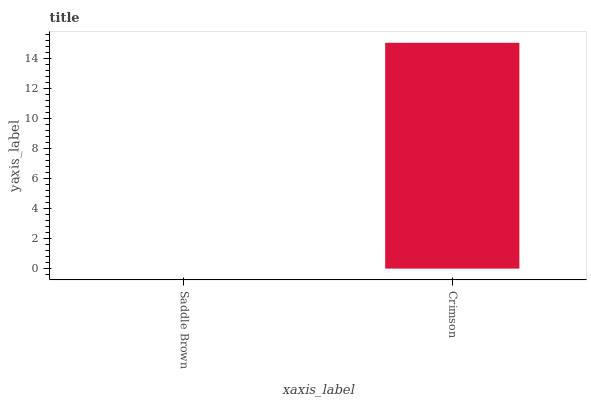Is Saddle Brown the minimum?
Answer yes or no. Yes. Is Crimson the maximum?
Answer yes or no. Yes. Is Crimson the minimum?
Answer yes or no. No. Is Crimson greater than Saddle Brown?
Answer yes or no. Yes. Is Saddle Brown less than Crimson?
Answer yes or no. Yes. Is Saddle Brown greater than Crimson?
Answer yes or no. No. Is Crimson less than Saddle Brown?
Answer yes or no. No. Is Crimson the high median?
Answer yes or no. Yes. Is Saddle Brown the low median?
Answer yes or no. Yes. Is Saddle Brown the high median?
Answer yes or no. No. Is Crimson the low median?
Answer yes or no. No. 